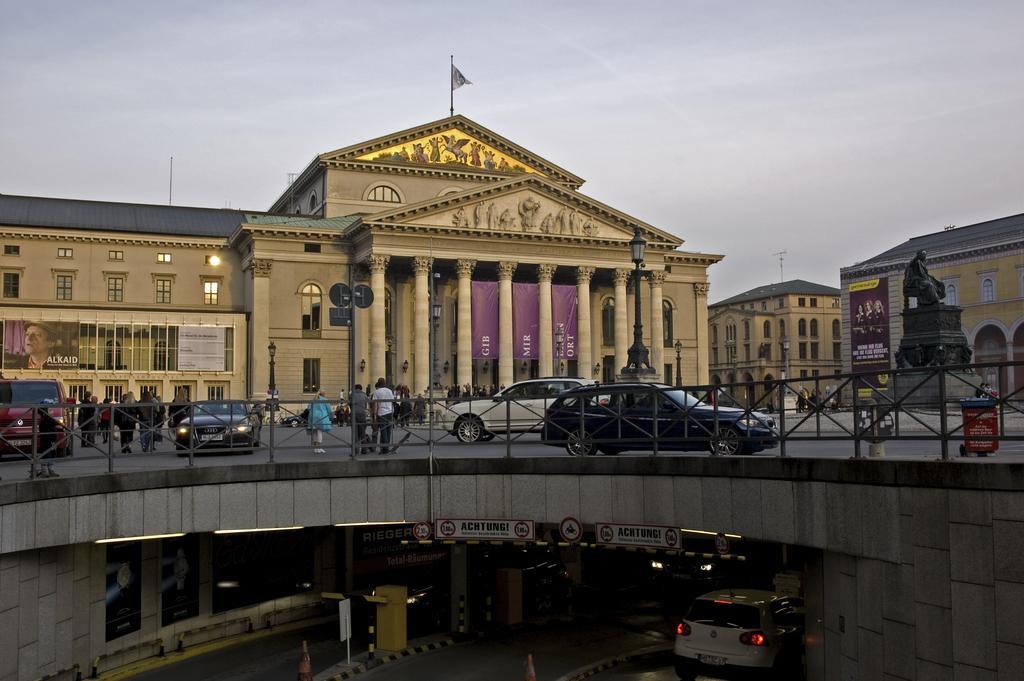Can you describe this image briefly? In the middle of the picture, we see people standing and the cars moving on the bridge. We even see street lights, poles and boards. Under the bridge, we see the white car moving on the road. Behind the cars, we see buildings. At the top of the building, we see a flag. On the right side of the picture, we see the statue of the man standing. At the top of the picture, we see the sky. 